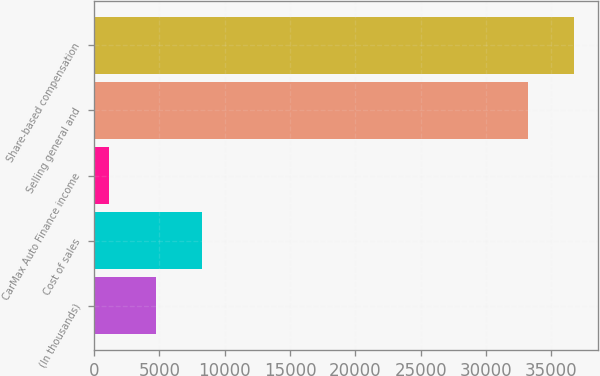<chart> <loc_0><loc_0><loc_500><loc_500><bar_chart><fcel>(In thousands)<fcel>Cost of sales<fcel>CarMax Auto Finance income<fcel>Selling general and<fcel>Share-based compensation<nl><fcel>4714.7<fcel>8248.4<fcel>1181<fcel>33201<fcel>36734.7<nl></chart> 